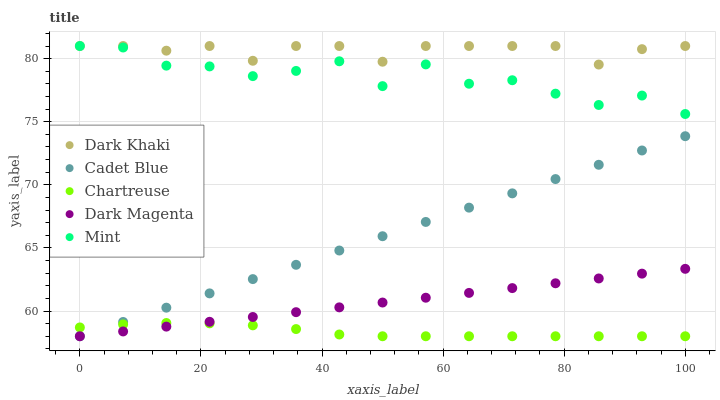Does Chartreuse have the minimum area under the curve?
Answer yes or no. Yes. Does Dark Khaki have the maximum area under the curve?
Answer yes or no. Yes. Does Cadet Blue have the minimum area under the curve?
Answer yes or no. No. Does Cadet Blue have the maximum area under the curve?
Answer yes or no. No. Is Dark Magenta the smoothest?
Answer yes or no. Yes. Is Mint the roughest?
Answer yes or no. Yes. Is Chartreuse the smoothest?
Answer yes or no. No. Is Chartreuse the roughest?
Answer yes or no. No. Does Chartreuse have the lowest value?
Answer yes or no. Yes. Does Mint have the lowest value?
Answer yes or no. No. Does Mint have the highest value?
Answer yes or no. Yes. Does Cadet Blue have the highest value?
Answer yes or no. No. Is Dark Magenta less than Dark Khaki?
Answer yes or no. Yes. Is Dark Khaki greater than Cadet Blue?
Answer yes or no. Yes. Does Dark Magenta intersect Chartreuse?
Answer yes or no. Yes. Is Dark Magenta less than Chartreuse?
Answer yes or no. No. Is Dark Magenta greater than Chartreuse?
Answer yes or no. No. Does Dark Magenta intersect Dark Khaki?
Answer yes or no. No. 